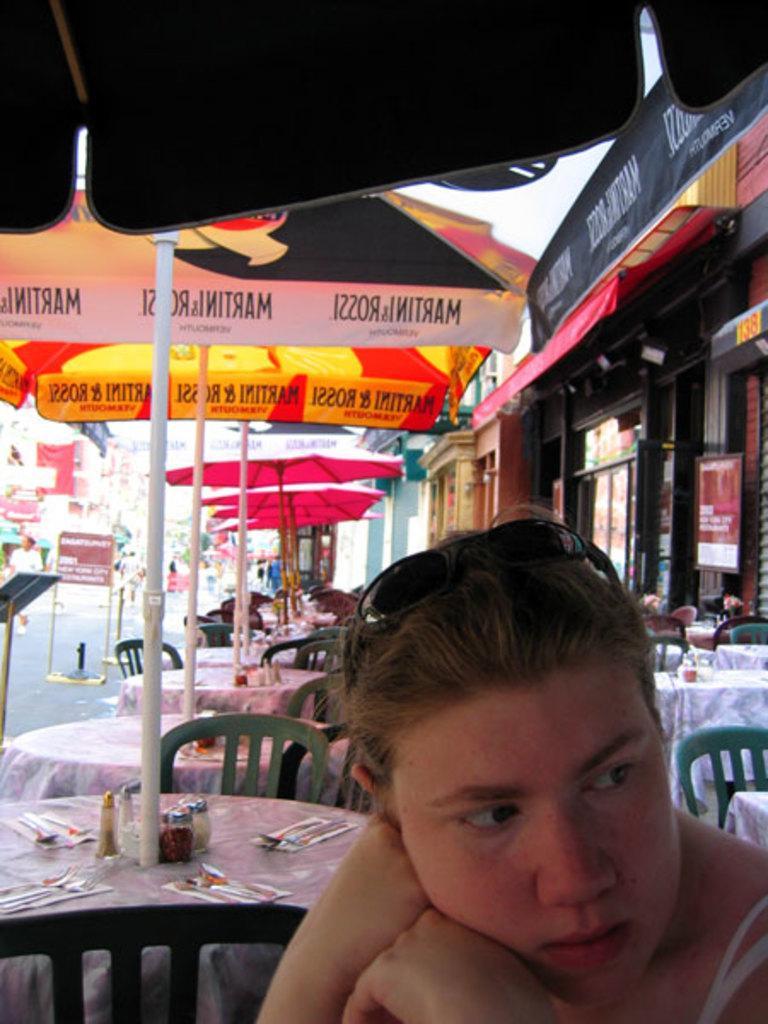Please provide a concise description of this image. In this picture I can see there is a woman sitting and she is looking at the right side. There are few tables and chairs in the backdrop, m with umbrellas and there is a building on right side and there is a walkway at left side. 